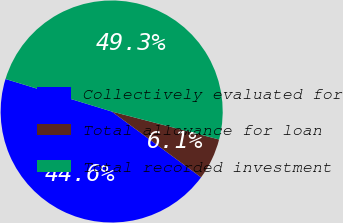Convert chart to OTSL. <chart><loc_0><loc_0><loc_500><loc_500><pie_chart><fcel>Collectively evaluated for<fcel>Total allowance for loan<fcel>Total recorded investment<nl><fcel>44.62%<fcel>6.05%<fcel>49.33%<nl></chart> 